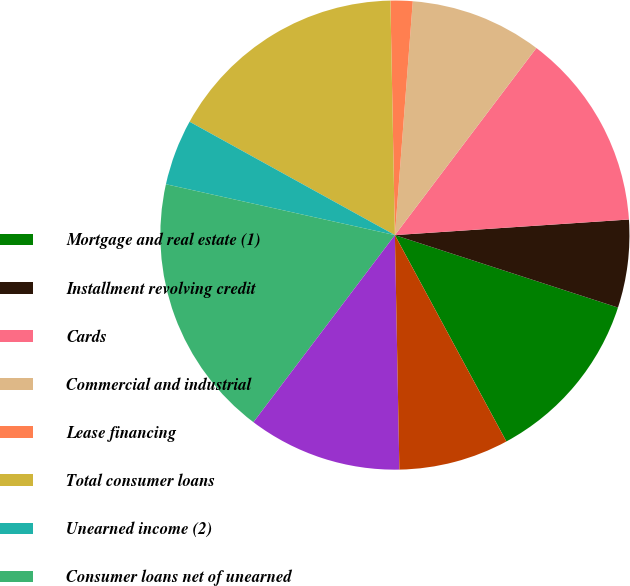Convert chart. <chart><loc_0><loc_0><loc_500><loc_500><pie_chart><fcel>Mortgage and real estate (1)<fcel>Installment revolving credit<fcel>Cards<fcel>Commercial and industrial<fcel>Lease financing<fcel>Total consumer loans<fcel>Unearned income (2)<fcel>Consumer loans net of unearned<fcel>Loans to financial<fcel>Governments and official<nl><fcel>12.12%<fcel>6.06%<fcel>13.64%<fcel>9.09%<fcel>1.52%<fcel>16.67%<fcel>4.55%<fcel>18.18%<fcel>10.61%<fcel>7.58%<nl></chart> 